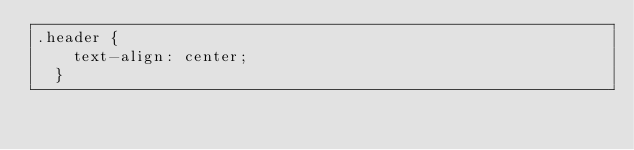Convert code to text. <code><loc_0><loc_0><loc_500><loc_500><_CSS_>.header {
    text-align: center;
  }
  </code> 